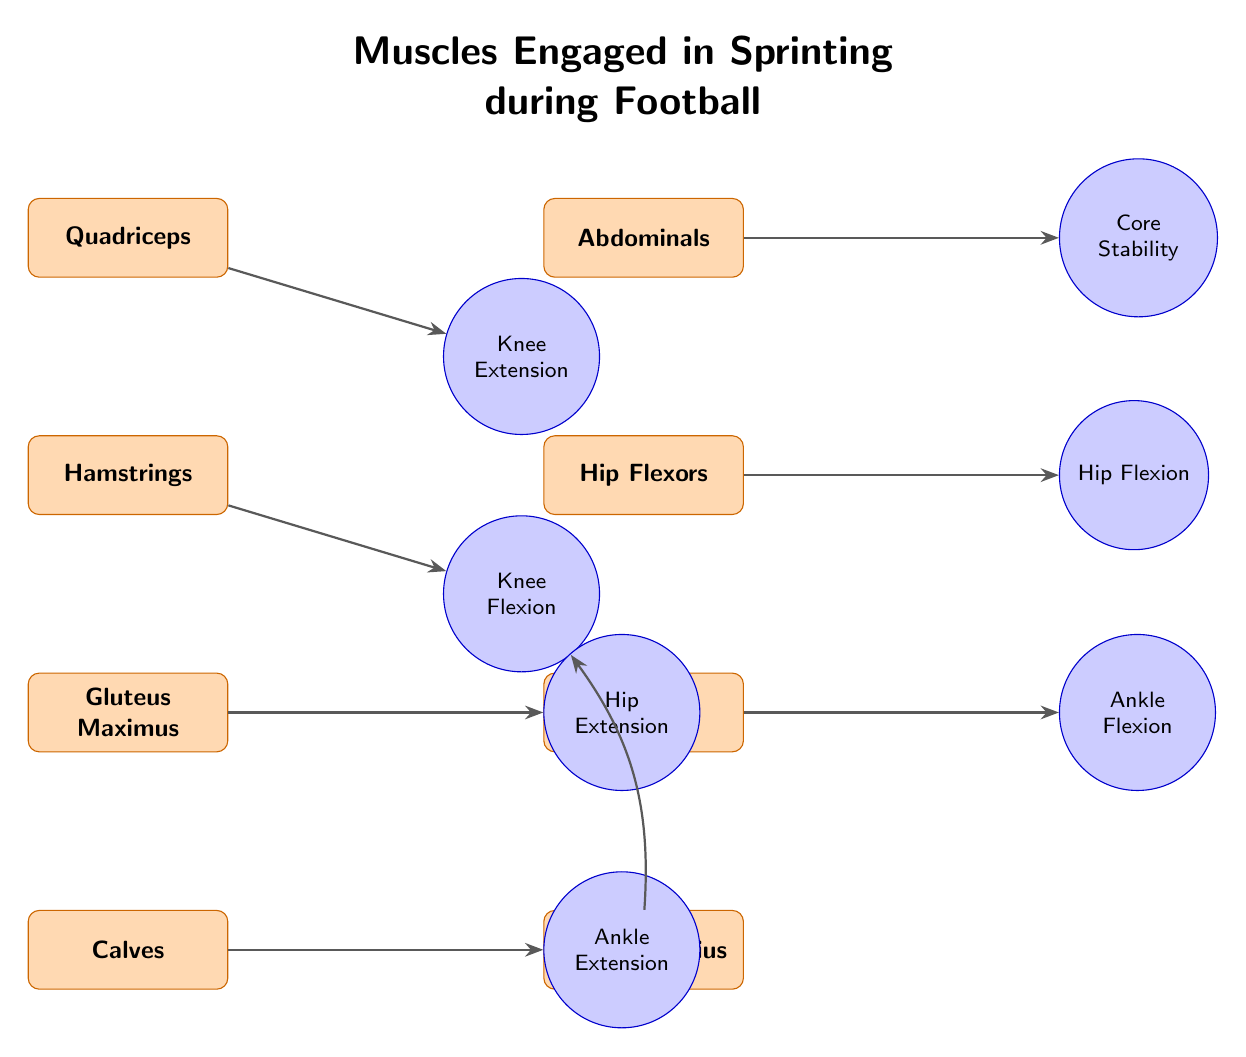What are the muscles engaged in sprinting? The diagram lists four primary muscles engaged in sprinting: Quadriceps, Hamstrings, Gluteus Maximus, and Calves. These all contribute to the running action.
Answer: Quadriceps, Hamstrings, Gluteus Maximus, Calves How many actions are associated with the Calves muscle? The Calves muscle is connected to one action in the diagram, which is Ankle Extension.
Answer: 1 What action do the Quadriceps facilitate? The Quadriceps facilitate the action of Knee Extension, as indicated by the connection from the Quadriceps to that action node.
Answer: Knee Extension Which muscle is responsible for Hip Flexion? The muscle responsible for Hip Flexion is the Hip Flexors, as shown in the diagram where the Hip Flexors connect to the Hip Flexion action.
Answer: Hip Flexors What is the connection between the Gluteus Maximus and the Hamstrings? Both the Gluteus Maximus and Hamstrings contribute to separate but opposing actions; the Gluteus Maximus connects to Hip Extension while the Hamstrings connect to Knee Flexion. This relationship illustrates the balance of muscle engagement during running.
Answer: Opposing actions How many total actions are shown in the diagram? There are a total of seven actions listed in the diagram, corresponding to the muscles: Knee Extension, Knee Flexion, Hip Extension, Ankle Extension, Core Stability, Hip Flexion, and Ankle Flexion.
Answer: 7 Which muscle has a direct connection to the Gastrocnemius? The Gastrocnemius has a direct connection leading to the Knee Flexion action, indicated by the bending arrow connecting it to that action node.
Answer: Knee Flexion What function does the Abdominals muscle serve in sprinting? The Abdominals muscle serves the function of Core Stability during sprinting, according to its connection to the corresponding action in the diagram.
Answer: Core Stability Which two actions are facilitated by the muscles above the Hamstrings? The two actions facilitated by the muscles above the Hamstrings are Knee Extension (by the Quadriceps) and Core Stability (by the Abdominals), indicating their role in supporting sprinting mechanics.
Answer: Knee Extension, Core Stability 